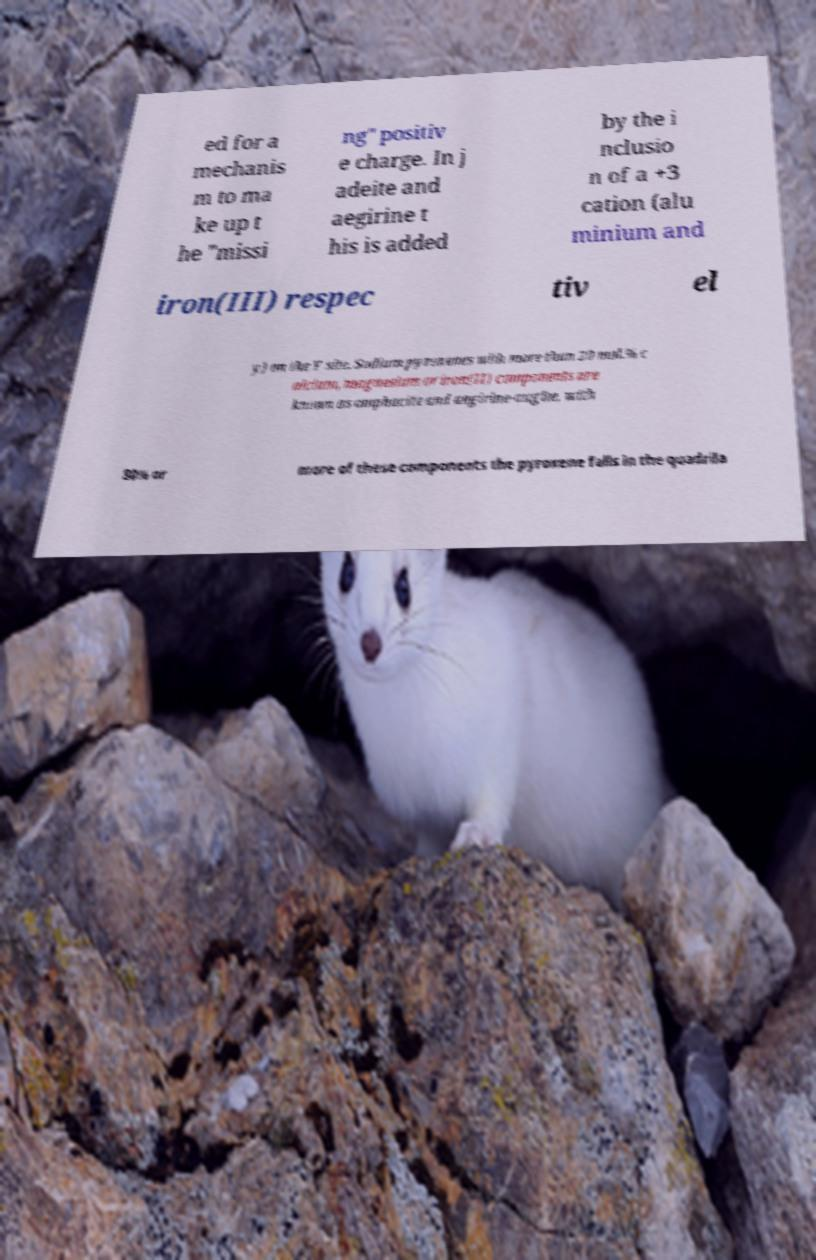Can you accurately transcribe the text from the provided image for me? ed for a mechanis m to ma ke up t he "missi ng" positiv e charge. In j adeite and aegirine t his is added by the i nclusio n of a +3 cation (alu minium and iron(III) respec tiv el y) on the Y site. Sodium pyroxenes with more than 20 mol.% c alcium, magnesium or iron(II) components are known as omphacite and aegirine-augite, with 80% or more of these components the pyroxene falls in the quadrila 